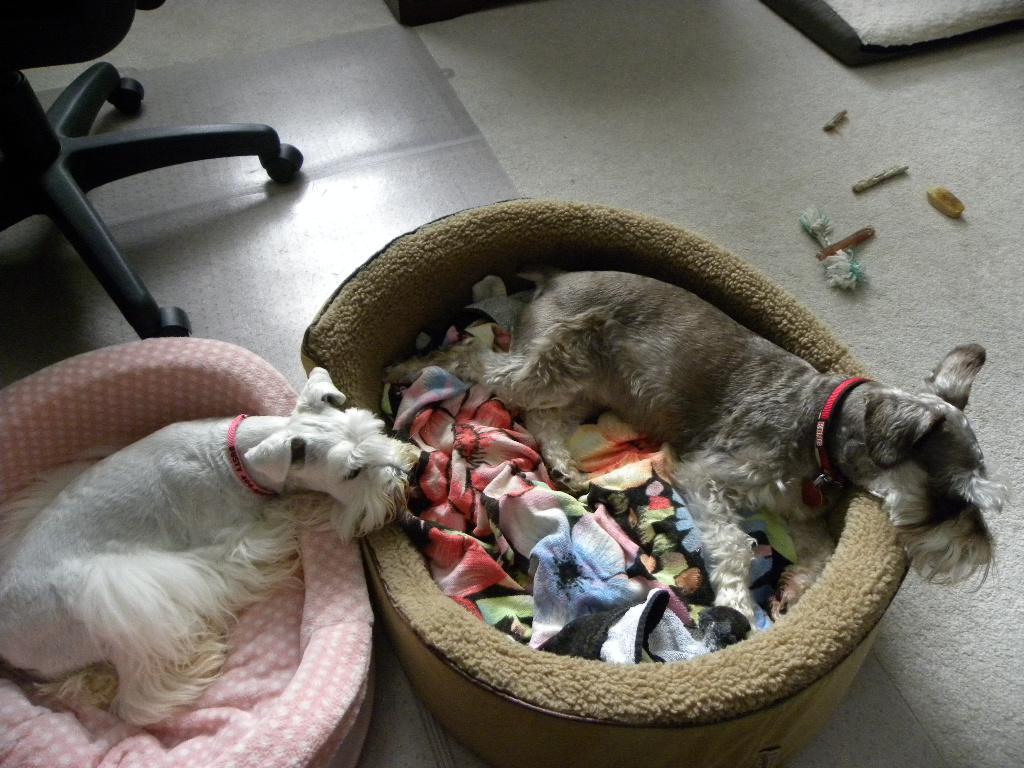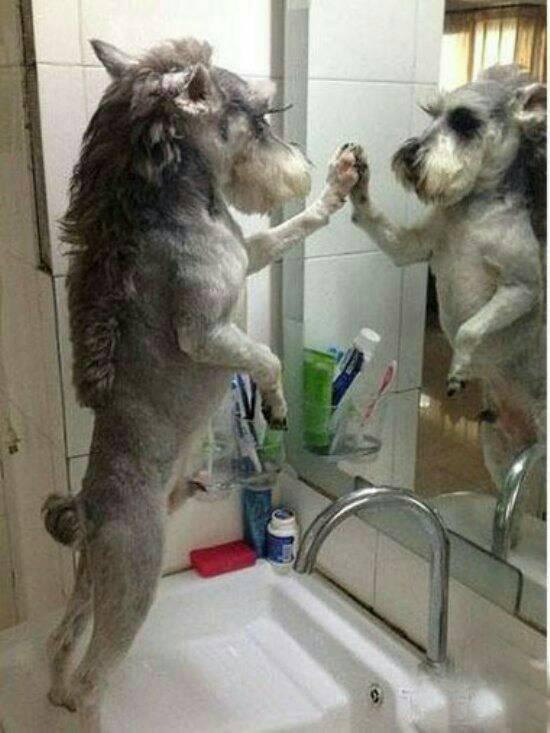The first image is the image on the left, the second image is the image on the right. For the images shown, is this caption "One dog's teeth are visible." true? Answer yes or no. No. The first image is the image on the left, the second image is the image on the right. Assess this claim about the two images: "One image shows a dog standing upright with at least one paw propped on something flat, and the other image includes at least two schnauzers.". Correct or not? Answer yes or no. Yes. 